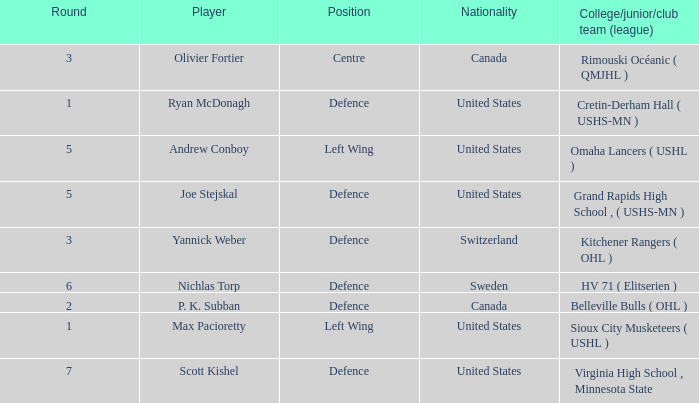Give me the full table as a dictionary. {'header': ['Round', 'Player', 'Position', 'Nationality', 'College/junior/club team (league)'], 'rows': [['3', 'Olivier Fortier', 'Centre', 'Canada', 'Rimouski Océanic ( QMJHL )'], ['1', 'Ryan McDonagh', 'Defence', 'United States', 'Cretin-Derham Hall ( USHS-MN )'], ['5', 'Andrew Conboy', 'Left Wing', 'United States', 'Omaha Lancers ( USHL )'], ['5', 'Joe Stejskal', 'Defence', 'United States', 'Grand Rapids High School , ( USHS-MN )'], ['3', 'Yannick Weber', 'Defence', 'Switzerland', 'Kitchener Rangers ( OHL )'], ['6', 'Nichlas Torp', 'Defence', 'Sweden', 'HV 71 ( Elitserien )'], ['2', 'P. K. Subban', 'Defence', 'Canada', 'Belleville Bulls ( OHL )'], ['1', 'Max Pacioretty', 'Left Wing', 'United States', 'Sioux City Musketeers ( USHL )'], ['7', 'Scott Kishel', 'Defence', 'United States', 'Virginia High School , Minnesota State']]} Which player from the United States plays defence and was chosen before round 5? Ryan McDonagh. 